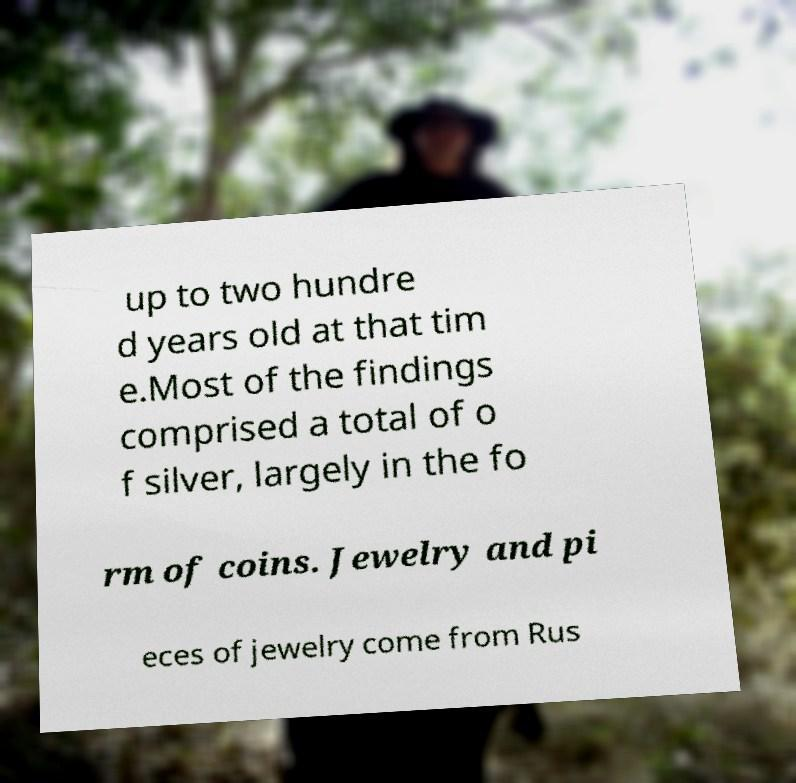Please identify and transcribe the text found in this image. up to two hundre d years old at that tim e.Most of the findings comprised a total of o f silver, largely in the fo rm of coins. Jewelry and pi eces of jewelry come from Rus 